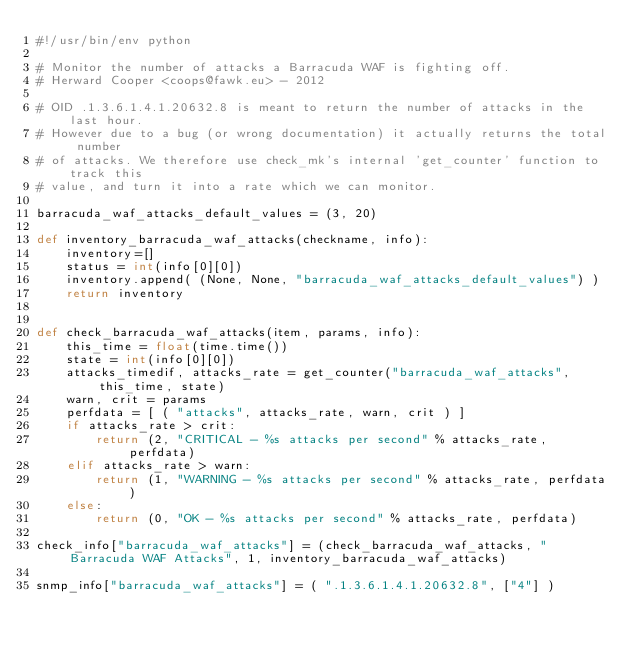Convert code to text. <code><loc_0><loc_0><loc_500><loc_500><_Python_>#!/usr/bin/env python

# Monitor the number of attacks a Barracuda WAF is fighting off.
# Herward Cooper <coops@fawk.eu> - 2012

# OID .1.3.6.1.4.1.20632.8 is meant to return the number of attacks in the last hour.
# However due to a bug (or wrong documentation) it actually returns the total number
# of attacks. We therefore use check_mk's internal 'get_counter' function to track this
# value, and turn it into a rate which we can monitor.

barracuda_waf_attacks_default_values = (3, 20)

def inventory_barracuda_waf_attacks(checkname, info):
    inventory=[]
    status = int(info[0][0])
    inventory.append( (None, None, "barracuda_waf_attacks_default_values") )
    return inventory


def check_barracuda_waf_attacks(item, params, info):
    this_time = float(time.time())
    state = int(info[0][0])
    attacks_timedif, attacks_rate = get_counter("barracuda_waf_attacks", this_time, state)
    warn, crit = params
    perfdata = [ ( "attacks", attacks_rate, warn, crit ) ]
    if attacks_rate > crit:
        return (2, "CRITICAL - %s attacks per second" % attacks_rate, perfdata)
    elif attacks_rate > warn:
        return (1, "WARNING - %s attacks per second" % attacks_rate, perfdata)
    else:
        return (0, "OK - %s attacks per second" % attacks_rate, perfdata)

check_info["barracuda_waf_attacks"] = (check_barracuda_waf_attacks, "Barracuda WAF Attacks", 1, inventory_barracuda_waf_attacks)

snmp_info["barracuda_waf_attacks"] = ( ".1.3.6.1.4.1.20632.8", ["4"] )</code> 